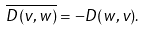<formula> <loc_0><loc_0><loc_500><loc_500>\overline { D ( v , w ) } = - D ( w , v ) .</formula> 